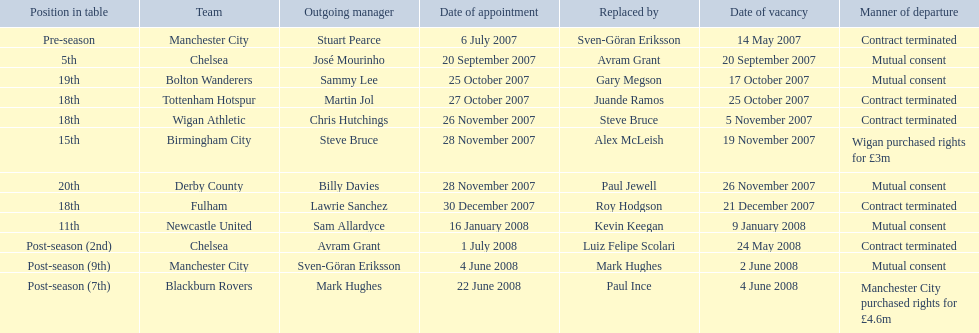Avram grant was with chelsea for at least how many years? 1. 